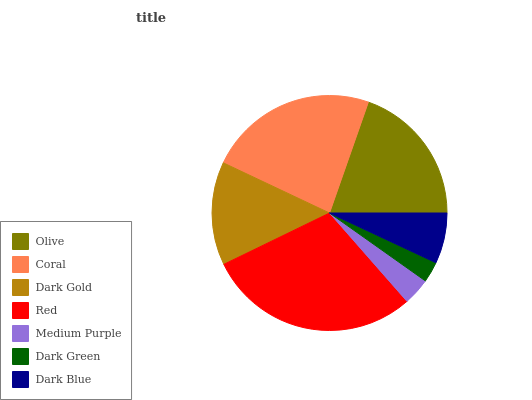Is Dark Green the minimum?
Answer yes or no. Yes. Is Red the maximum?
Answer yes or no. Yes. Is Coral the minimum?
Answer yes or no. No. Is Coral the maximum?
Answer yes or no. No. Is Coral greater than Olive?
Answer yes or no. Yes. Is Olive less than Coral?
Answer yes or no. Yes. Is Olive greater than Coral?
Answer yes or no. No. Is Coral less than Olive?
Answer yes or no. No. Is Dark Gold the high median?
Answer yes or no. Yes. Is Dark Gold the low median?
Answer yes or no. Yes. Is Dark Blue the high median?
Answer yes or no. No. Is Medium Purple the low median?
Answer yes or no. No. 